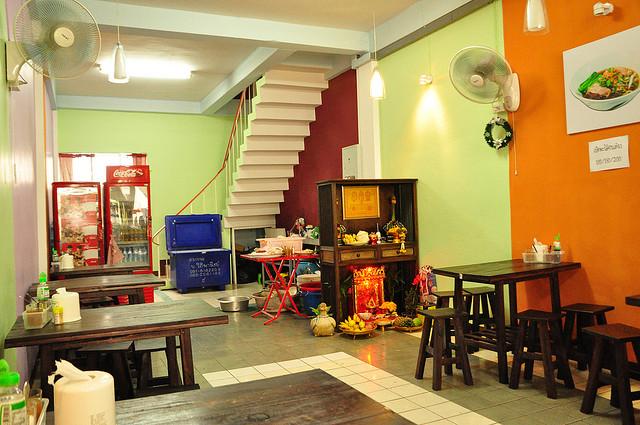Where are the stairs?
Quick response, please. In back. What colors are the walls?
Be succinct. Green and orange. Is there soda in the room?
Answer briefly. Yes. 